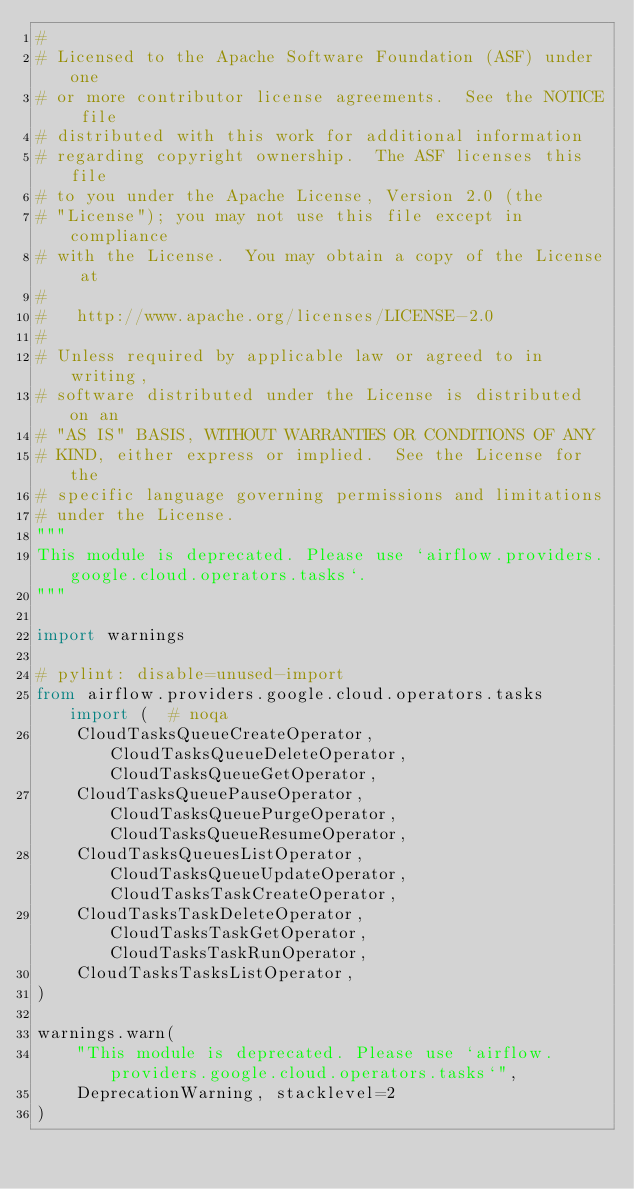Convert code to text. <code><loc_0><loc_0><loc_500><loc_500><_Python_>#
# Licensed to the Apache Software Foundation (ASF) under one
# or more contributor license agreements.  See the NOTICE file
# distributed with this work for additional information
# regarding copyright ownership.  The ASF licenses this file
# to you under the Apache License, Version 2.0 (the
# "License"); you may not use this file except in compliance
# with the License.  You may obtain a copy of the License at
#
#   http://www.apache.org/licenses/LICENSE-2.0
#
# Unless required by applicable law or agreed to in writing,
# software distributed under the License is distributed on an
# "AS IS" BASIS, WITHOUT WARRANTIES OR CONDITIONS OF ANY
# KIND, either express or implied.  See the License for the
# specific language governing permissions and limitations
# under the License.
"""
This module is deprecated. Please use `airflow.providers.google.cloud.operators.tasks`.
"""

import warnings

# pylint: disable=unused-import
from airflow.providers.google.cloud.operators.tasks import (  # noqa
    CloudTasksQueueCreateOperator, CloudTasksQueueDeleteOperator, CloudTasksQueueGetOperator,
    CloudTasksQueuePauseOperator, CloudTasksQueuePurgeOperator, CloudTasksQueueResumeOperator,
    CloudTasksQueuesListOperator, CloudTasksQueueUpdateOperator, CloudTasksTaskCreateOperator,
    CloudTasksTaskDeleteOperator, CloudTasksTaskGetOperator, CloudTasksTaskRunOperator,
    CloudTasksTasksListOperator,
)

warnings.warn(
    "This module is deprecated. Please use `airflow.providers.google.cloud.operators.tasks`",
    DeprecationWarning, stacklevel=2
)
</code> 